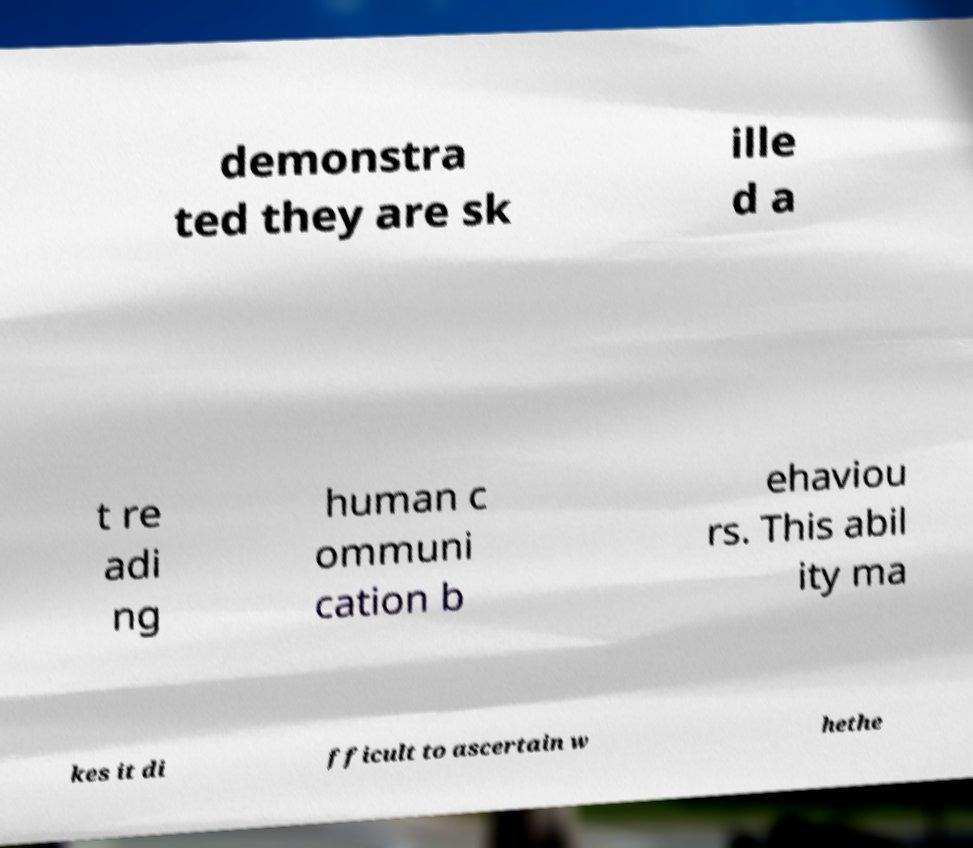I need the written content from this picture converted into text. Can you do that? demonstra ted they are sk ille d a t re adi ng human c ommuni cation b ehaviou rs. This abil ity ma kes it di fficult to ascertain w hethe 